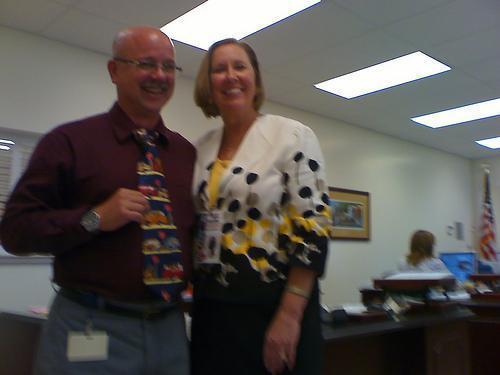How many flags are shown?
Give a very brief answer. 1. 